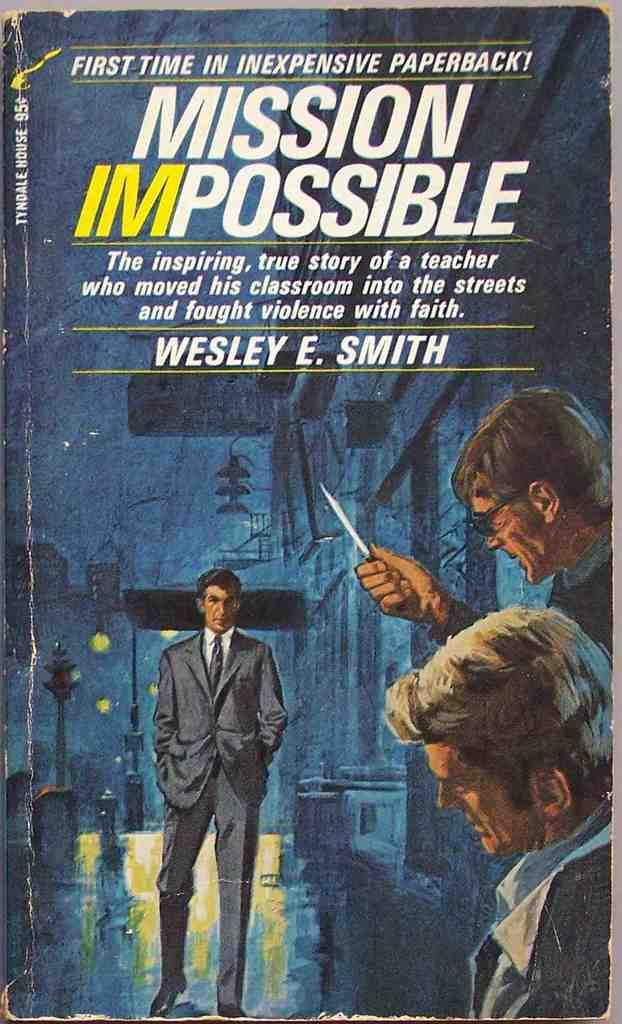What is the main object in the image? There is a book in the image. What can be seen on the book? There are people depicted on the book, and there is text on the book. What type of plant can be seen growing near the volcano in the image? There is no plant or volcano present in the image; it only features a book with people depicted on it and text. 